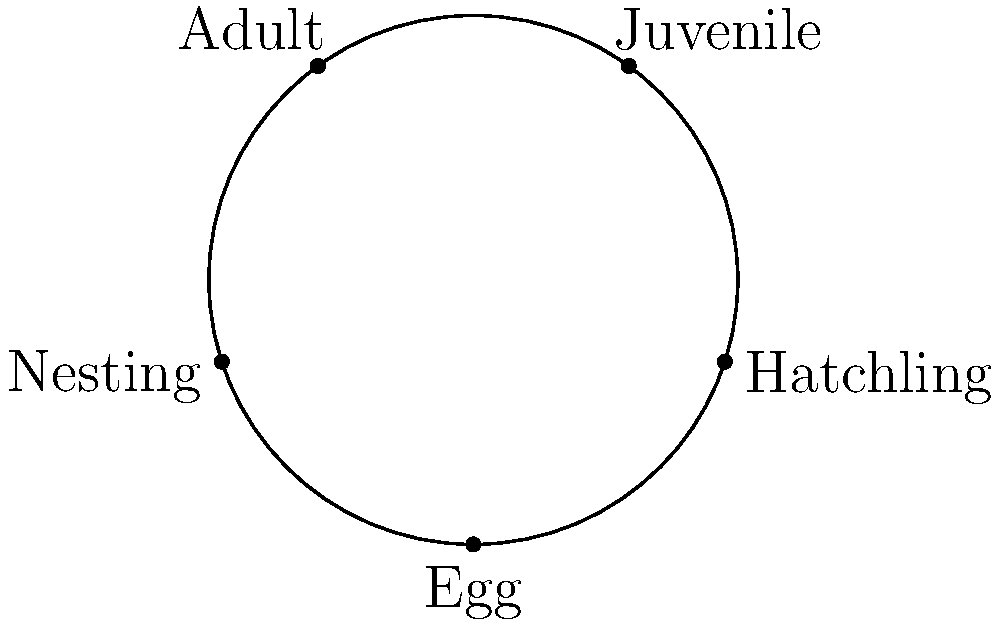In the circular diagram representing the life cycle of a sea turtle, which stage immediately follows the "Hatchling" phase? To answer this question, we need to analyze the circular diagram of the sea turtle's life cycle:

1. The diagram shows five stages arranged in a circular pattern, indicating a cyclical process.
2. The stages shown are: Egg, Hatchling, Juvenile, Adult, and Nesting.
3. In a circular life cycle diagram, we typically read the stages clockwise.
4. Starting from "Egg," we can see that the next stage is "Hatchling."
5. Following the clockwise direction, the stage immediately after "Hatchling" is "Juvenile."

This progression makes biological sense as well:
- After hatching from the egg, young sea turtles (hatchlings) make their way to the ocean.
- Once in the ocean, they enter the juvenile stage, where they continue to grow and develop.
- The juvenile stage is a critical period for sea turtles, as they face numerous threats and have a high mortality rate.

As a Venezuelan conservationist and reptile enthusiast, understanding this life cycle is crucial for implementing effective conservation strategies, especially for protecting vulnerable hatchlings and juveniles in coastal areas.
Answer: Juvenile 